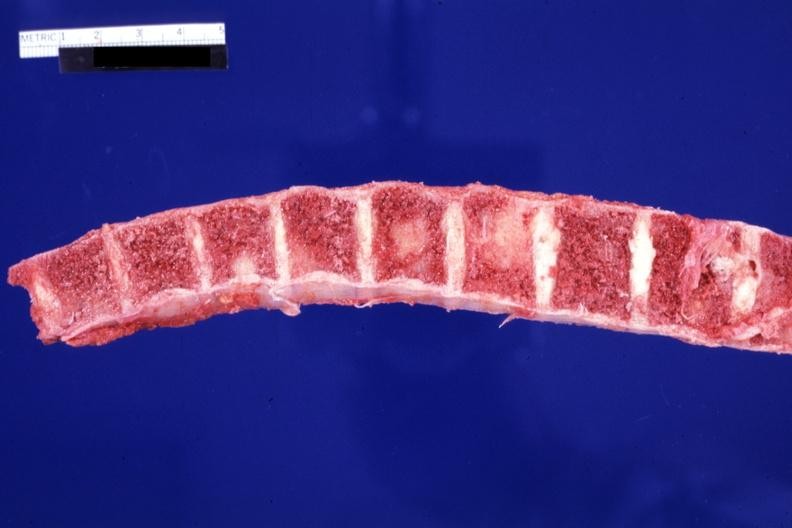s joints present?
Answer the question using a single word or phrase. Yes 